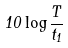Convert formula to latex. <formula><loc_0><loc_0><loc_500><loc_500>1 0 \log { \frac { T } { t _ { 1 } } }</formula> 